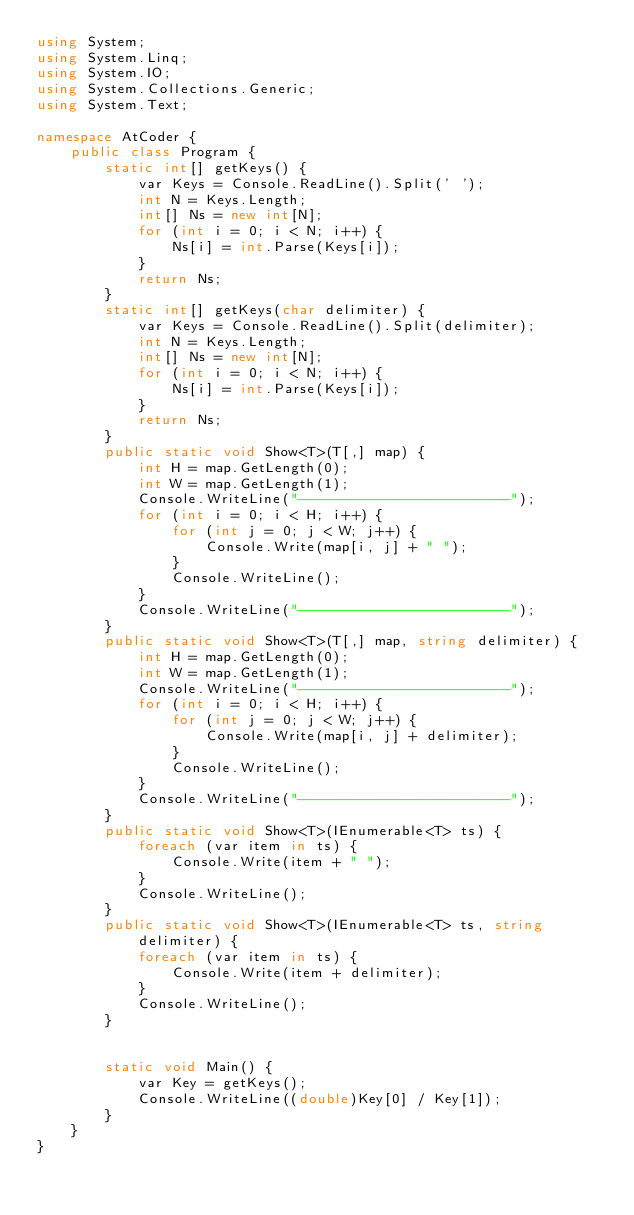<code> <loc_0><loc_0><loc_500><loc_500><_C#_>using System;
using System.Linq;
using System.IO;
using System.Collections.Generic;
using System.Text;

namespace AtCoder {
    public class Program {
        static int[] getKeys() {
            var Keys = Console.ReadLine().Split(' ');
            int N = Keys.Length;
            int[] Ns = new int[N];
            for (int i = 0; i < N; i++) {
                Ns[i] = int.Parse(Keys[i]);
            }
            return Ns;
        }
        static int[] getKeys(char delimiter) {
            var Keys = Console.ReadLine().Split(delimiter);
            int N = Keys.Length;
            int[] Ns = new int[N];
            for (int i = 0; i < N; i++) {
                Ns[i] = int.Parse(Keys[i]);
            }
            return Ns;
        }
        public static void Show<T>(T[,] map) {
            int H = map.GetLength(0);
            int W = map.GetLength(1);
            Console.WriteLine("-------------------------");
            for (int i = 0; i < H; i++) {
                for (int j = 0; j < W; j++) {
                    Console.Write(map[i, j] + " ");
                }
                Console.WriteLine();
            }
            Console.WriteLine("-------------------------");
        }
        public static void Show<T>(T[,] map, string delimiter) {
            int H = map.GetLength(0);
            int W = map.GetLength(1);
            Console.WriteLine("-------------------------");
            for (int i = 0; i < H; i++) {
                for (int j = 0; j < W; j++) {
                    Console.Write(map[i, j] + delimiter);
                }
                Console.WriteLine();
            }
            Console.WriteLine("-------------------------");
        }
        public static void Show<T>(IEnumerable<T> ts) {
            foreach (var item in ts) {
                Console.Write(item + " ");
            }
            Console.WriteLine();
        }
        public static void Show<T>(IEnumerable<T> ts, string delimiter) {
            foreach (var item in ts) {
                Console.Write(item + delimiter);
            }
            Console.WriteLine();
        }


        static void Main() {
            var Key = getKeys();
            Console.WriteLine((double)Key[0] / Key[1]);
        }
    }
}
</code> 